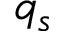Convert formula to latex. <formula><loc_0><loc_0><loc_500><loc_500>q _ { s }</formula> 